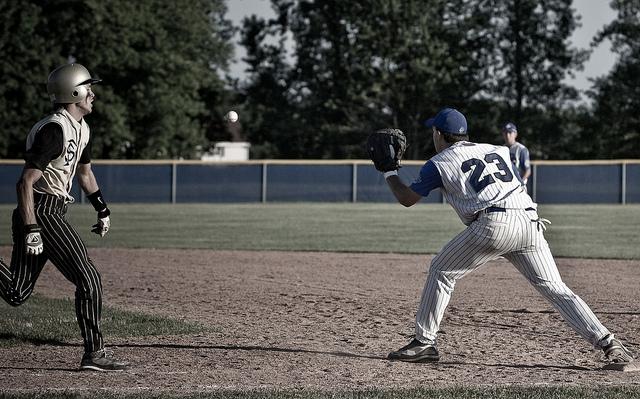What does both uniform pants have in common?
Be succinct. Stripes. What number is on the players shirt?
Write a very short answer. 23. What sport is this?
Give a very brief answer. Baseball. 